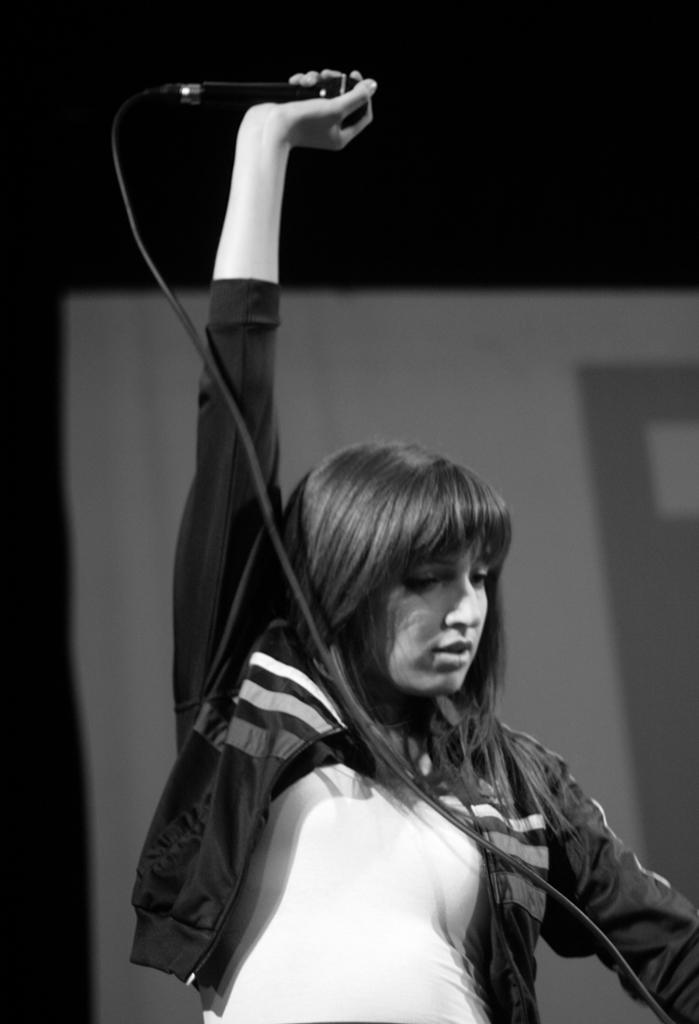What is the color scheme of the image? The image is black and white. Who is present in the image? There is a girl in the image. What is the girl doing in the image? The girl is standing in the image. What object is the girl holding in the image? The girl is holding a microphone in the image. Can you see any horns on the girl in the image? There are no horns visible on the girl in the image. What type of yard is shown in the image? There is no yard present in the image; it features a girl holding a microphone in a black and white setting. 